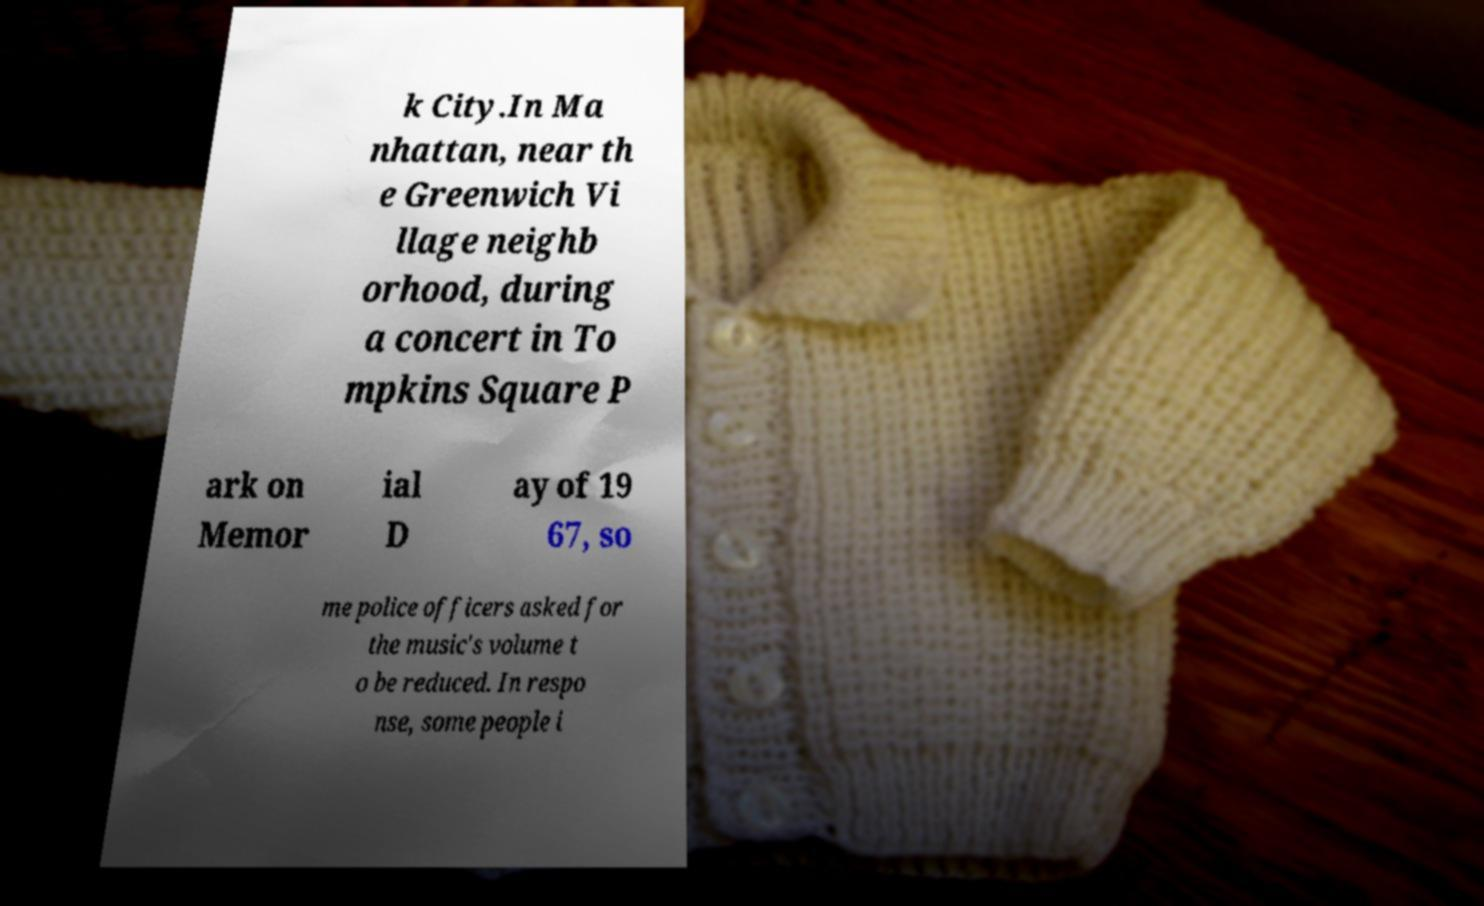Can you read and provide the text displayed in the image?This photo seems to have some interesting text. Can you extract and type it out for me? k City.In Ma nhattan, near th e Greenwich Vi llage neighb orhood, during a concert in To mpkins Square P ark on Memor ial D ay of 19 67, so me police officers asked for the music's volume t o be reduced. In respo nse, some people i 